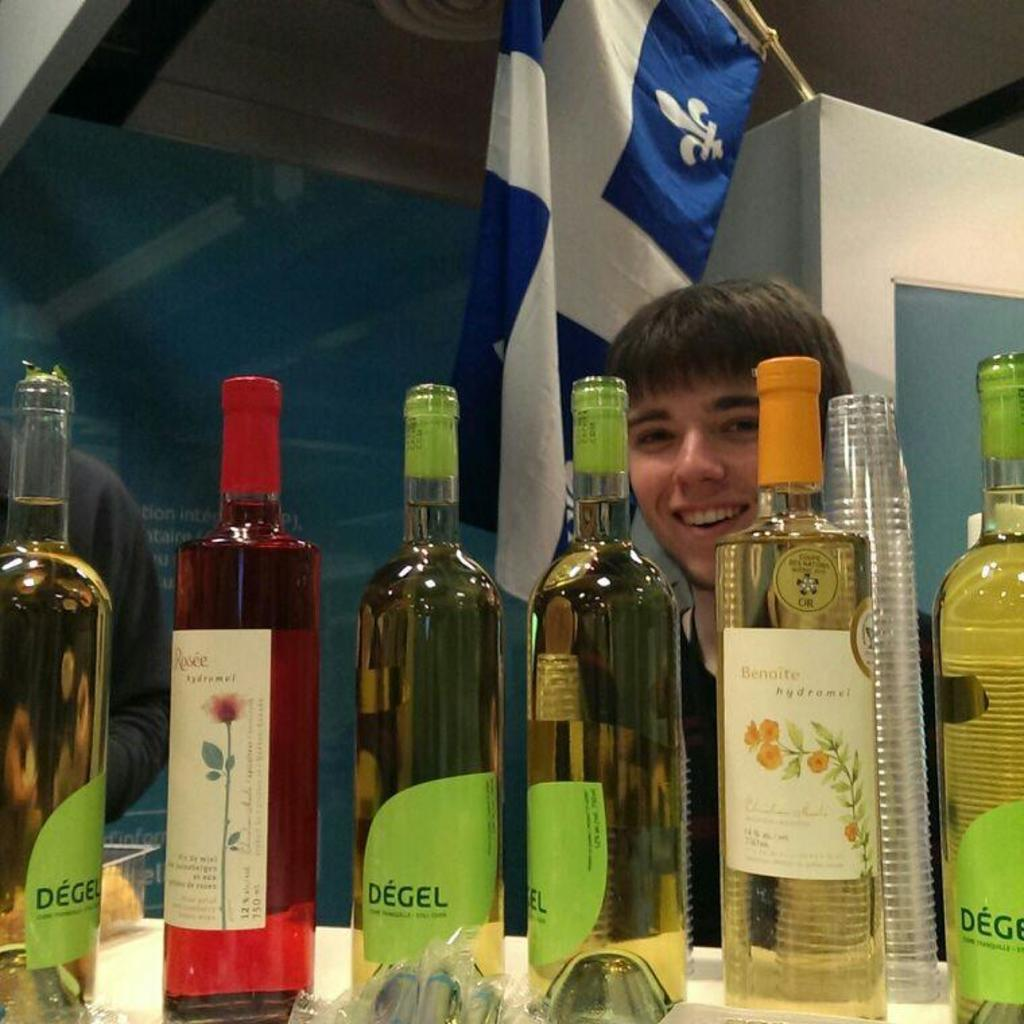What is the person in the image doing? The person is standing in the image and smiling. What can be seen in front of the person? There are wine bottles in front of the person. Is there any other notable object or feature in the image? Yes, there is a flag visible in the image. What type of machine is being operated by the person in the image? There is no machine present in the image; the person is simply standing and smiling. 